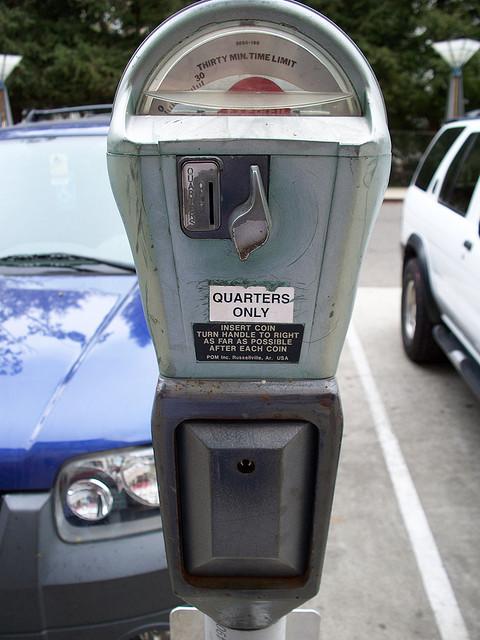How many slots are in the parking meter?
Give a very brief answer. 1. What coin does this machine take?
Write a very short answer. Quarters. Why do people put money in this machine?
Write a very short answer. To park. Are there rivets?
Write a very short answer. No. Is the meter expired?
Be succinct. Yes. What's the maximum amount of time I can park there?
Give a very brief answer. 30 minutes. What is the color of the car?
Quick response, please. Blue. Is the red car in a parking lot?
Answer briefly. No. Does the meter have any money in it?
Keep it brief. No. What color is the car?
Be succinct. Blue. Where are the cars parked?
Short answer required. Parking lot. Is the meter running?
Concise answer only. No. 